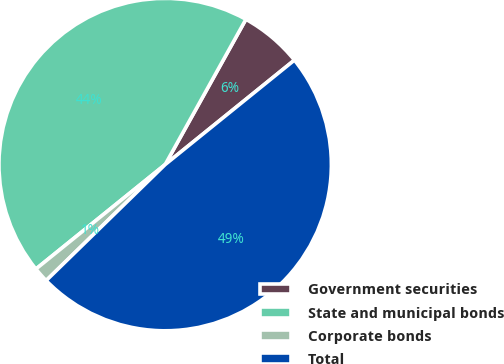<chart> <loc_0><loc_0><loc_500><loc_500><pie_chart><fcel>Government securities<fcel>State and municipal bonds<fcel>Corporate bonds<fcel>Total<nl><fcel>6.11%<fcel>43.89%<fcel>1.48%<fcel>48.52%<nl></chart> 